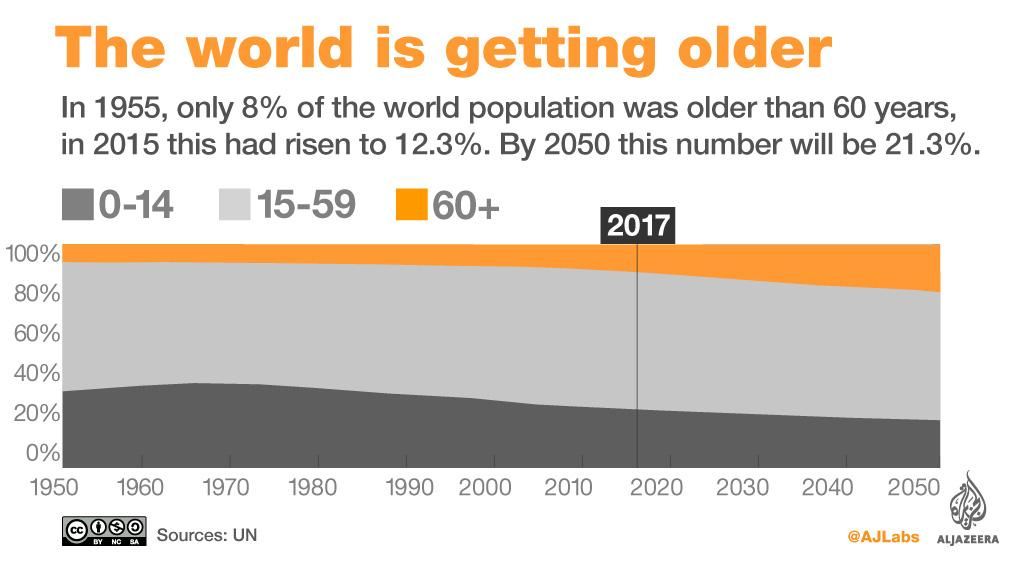Mention a couple of crucial points in this snapshot. By 2050, the population of individuals aged 60 and above is projected to increase. The population of individuals aged 0-14 is projected to decrease by 2050. 